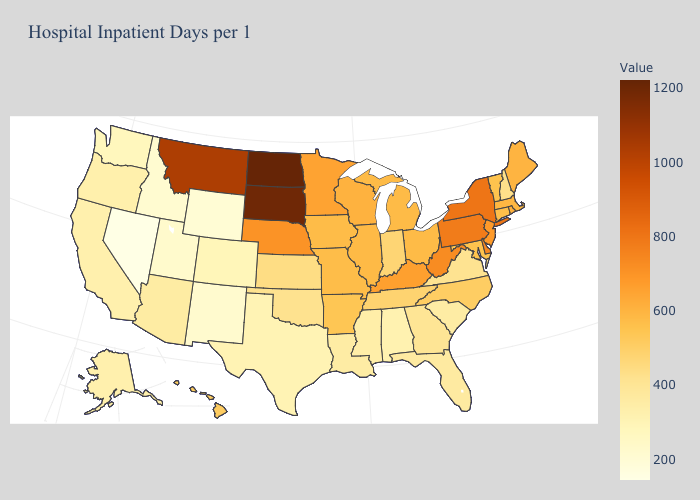Does Nevada have the lowest value in the USA?
Give a very brief answer. Yes. Which states have the lowest value in the MidWest?
Answer briefly. Kansas. Does Nevada have the lowest value in the USA?
Be succinct. Yes. Does Nevada have the lowest value in the West?
Short answer required. Yes. Among the states that border Alabama , does Tennessee have the highest value?
Keep it brief. Yes. Which states have the highest value in the USA?
Give a very brief answer. North Dakota. 